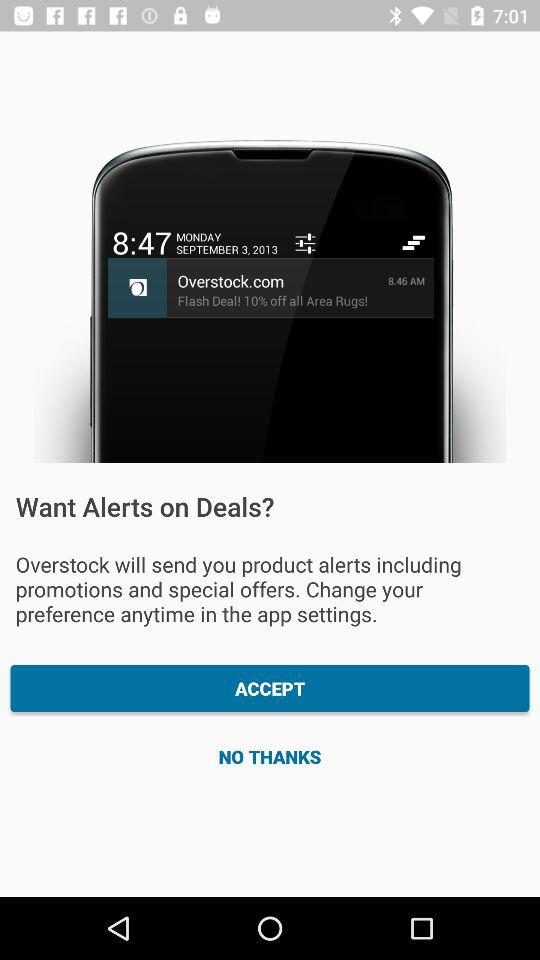What is the time on the screen? The times on the screen are 8:47 and 8:46 AM. 